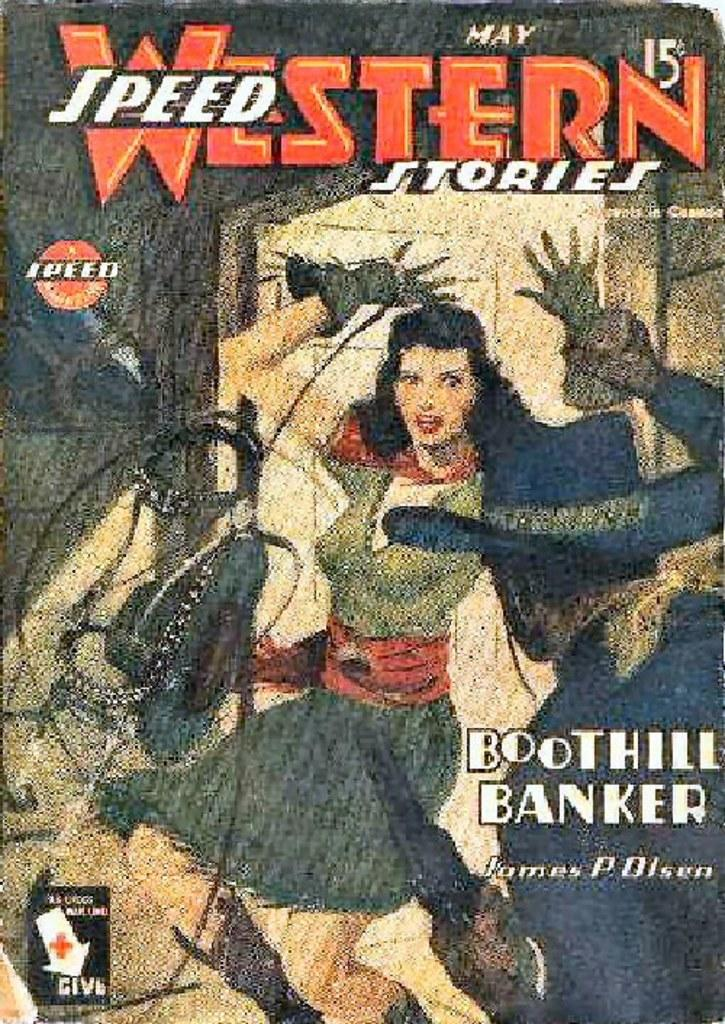Provide a one-sentence caption for the provided image. A comic book called Western Speed Stories by James P. Olsen. 